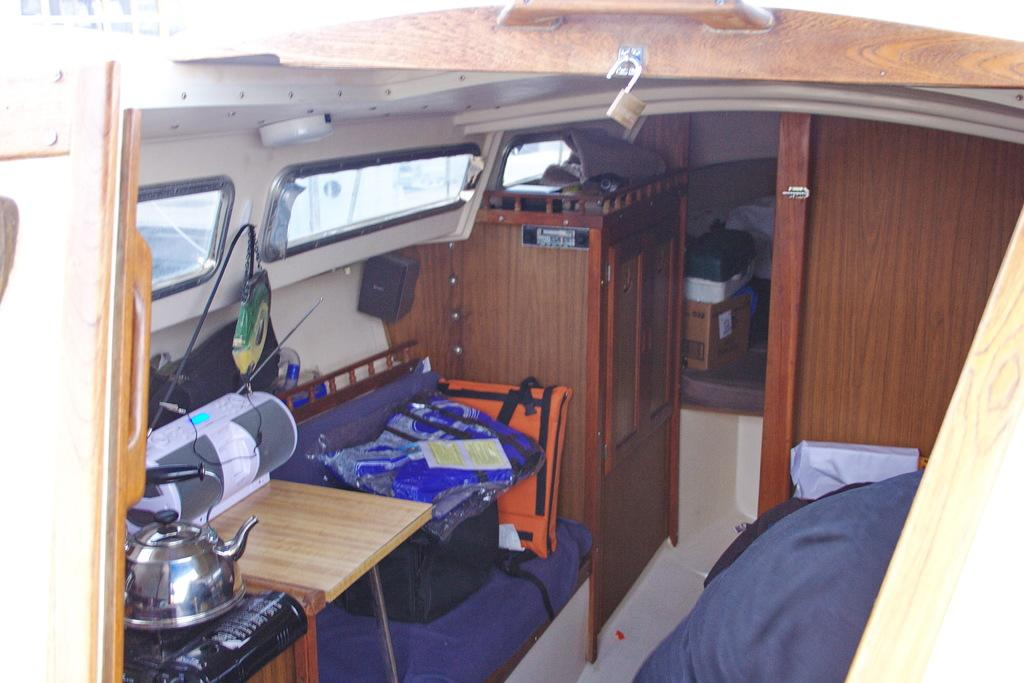What type of space is shown in the image? The image depicts a small room in a vehicle. What appliance can be seen in the room? There is a kettle in the room. What device is present for connecting electrical components? There is a connector box in the room. How can natural light enter the room? There is a window in the room. What piece of furniture is available for sitting? There is a stool in the room. What type of storage is available in the room? There are bags and cupboards in the room. What security feature is present in the room? There is a lock hanging on an object in the room. What type of writer can be seen working on a base with wings in the image? There is no writer or any object with wings present in the image. 